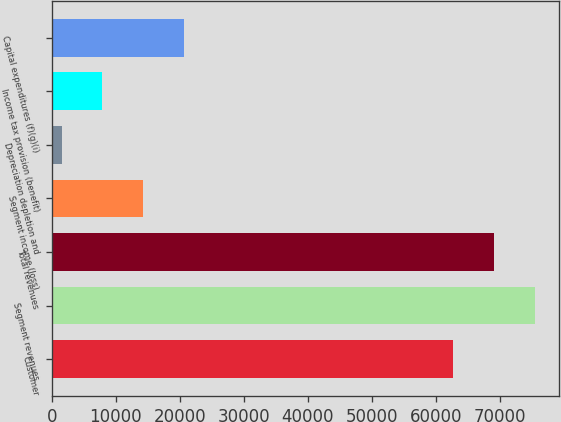Convert chart. <chart><loc_0><loc_0><loc_500><loc_500><bar_chart><fcel>Customer<fcel>Segment revenues<fcel>Total revenues<fcel>Segment income (loss)<fcel>Depreciation depletion and<fcel>Income tax provision (benefit)<fcel>Capital expenditures (f)(g)(i)<nl><fcel>62703<fcel>75439.8<fcel>69071.4<fcel>14265.8<fcel>1529<fcel>7897.4<fcel>20634.2<nl></chart> 